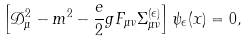<formula> <loc_0><loc_0><loc_500><loc_500>\left [ \mathcal { D } _ { \mu } ^ { 2 } - m ^ { 2 } - \frac { e } { 2 } g F _ { \mu \nu } \Sigma _ { \mu \nu } ^ { ( \epsilon ) } \right ] \psi _ { \epsilon } ( x ) = 0 ,</formula> 